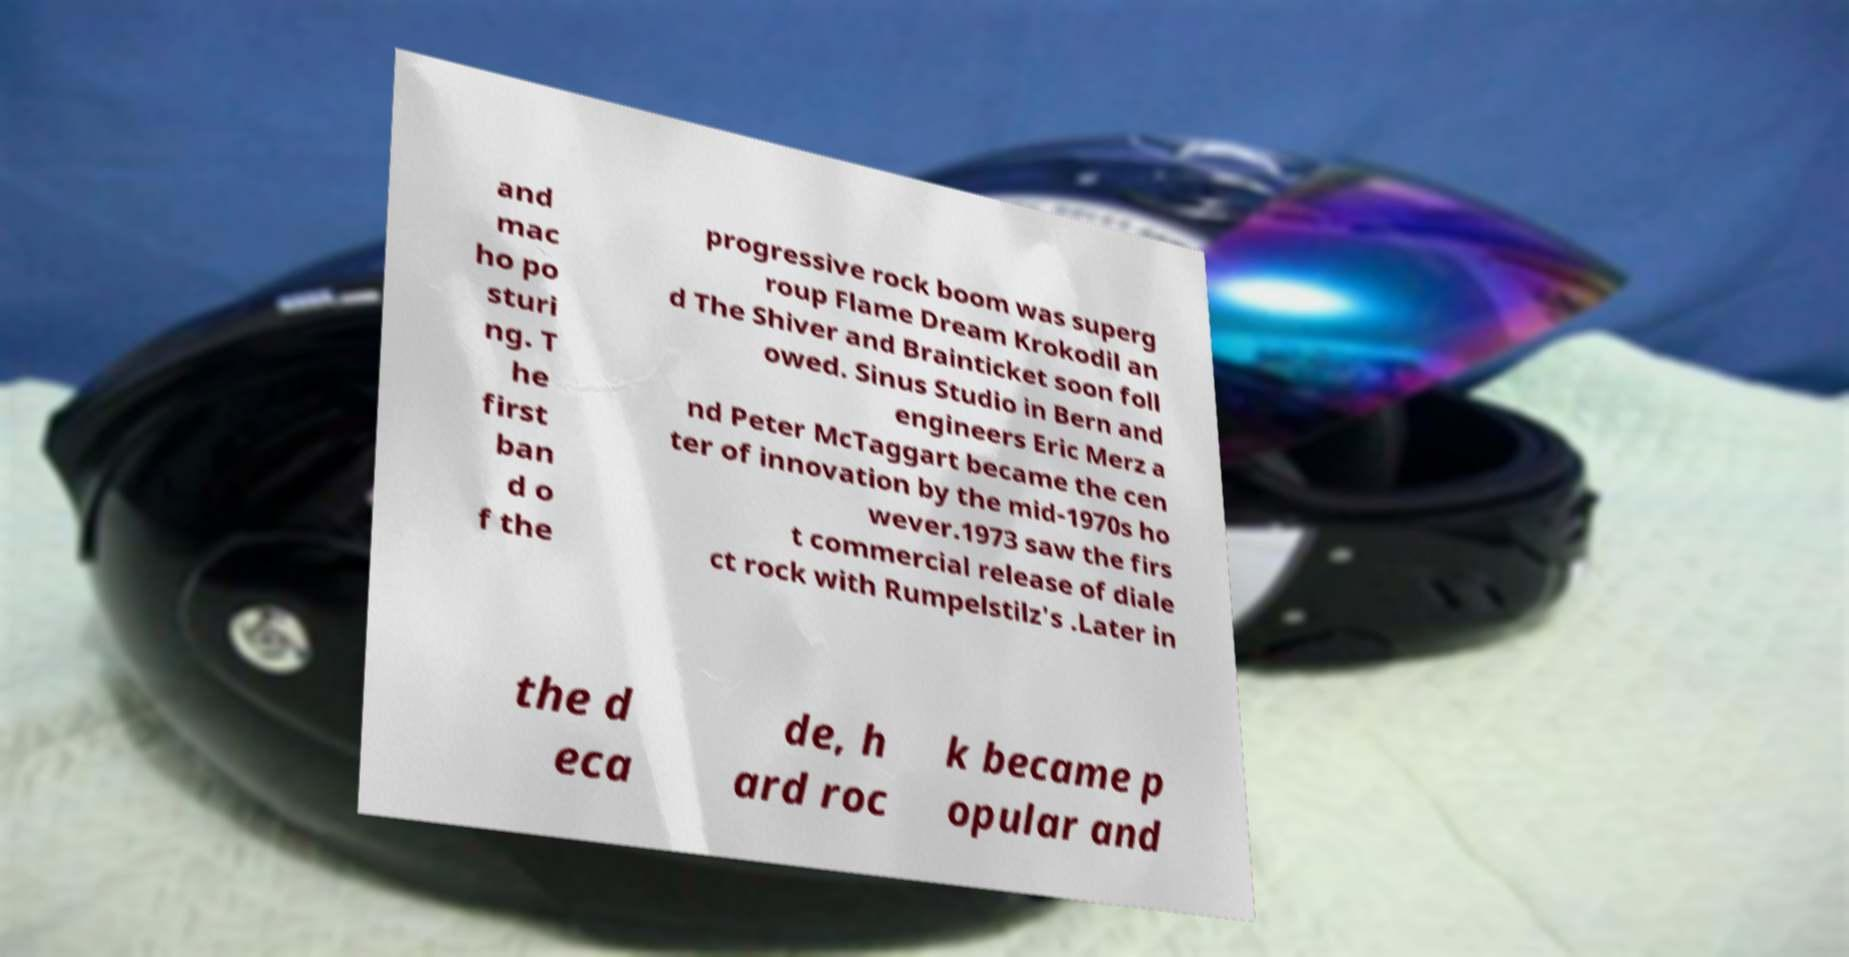Can you read and provide the text displayed in the image?This photo seems to have some interesting text. Can you extract and type it out for me? and mac ho po sturi ng. T he first ban d o f the progressive rock boom was superg roup Flame Dream Krokodil an d The Shiver and Brainticket soon foll owed. Sinus Studio in Bern and engineers Eric Merz a nd Peter McTaggart became the cen ter of innovation by the mid-1970s ho wever.1973 saw the firs t commercial release of diale ct rock with Rumpelstilz's .Later in the d eca de, h ard roc k became p opular and 